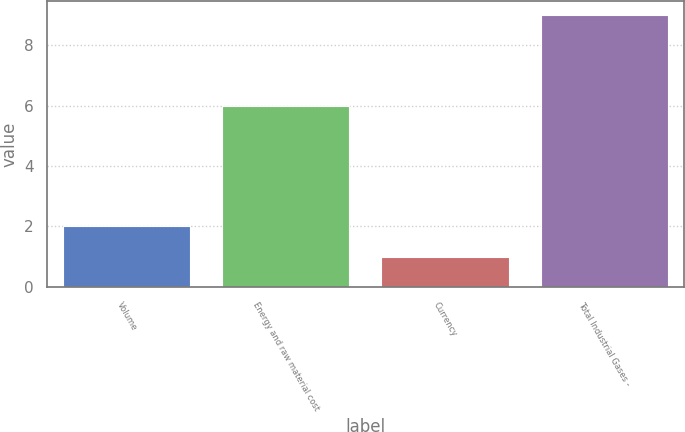Convert chart. <chart><loc_0><loc_0><loc_500><loc_500><bar_chart><fcel>Volume<fcel>Energy and raw material cost<fcel>Currency<fcel>Total Industrial Gases -<nl><fcel>2<fcel>6<fcel>1<fcel>9<nl></chart> 